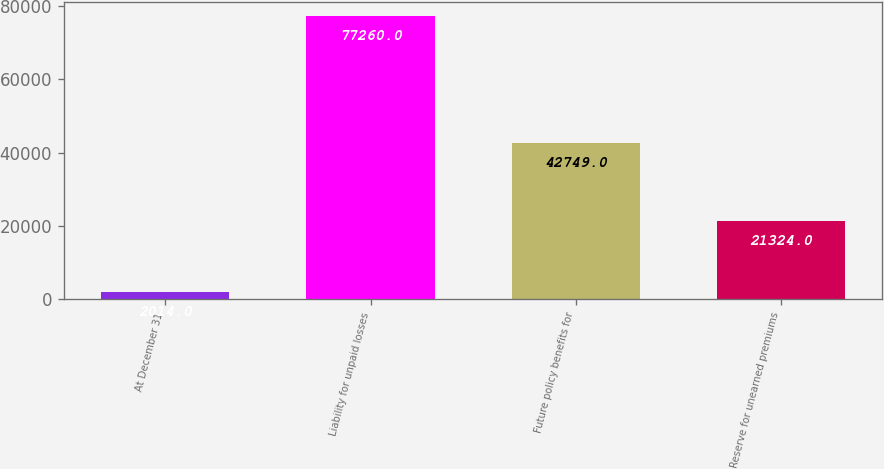<chart> <loc_0><loc_0><loc_500><loc_500><bar_chart><fcel>At December 31<fcel>Liability for unpaid losses<fcel>Future policy benefits for<fcel>Reserve for unearned premiums<nl><fcel>2014<fcel>77260<fcel>42749<fcel>21324<nl></chart> 